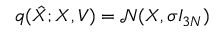Convert formula to latex. <formula><loc_0><loc_0><loc_500><loc_500>q ( \hat { X } ; { X } , { V } ) = \mathcal { N } ( { X } , \sigma I _ { 3 N } )</formula> 